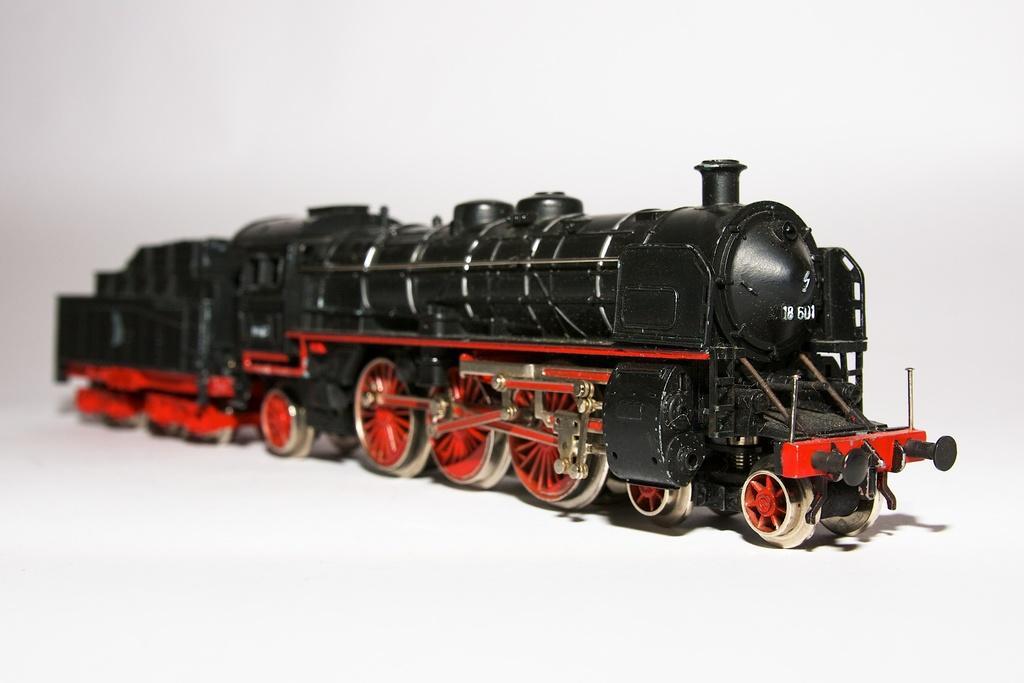Can you describe this image briefly? In the middle of this image, there is a black color toy train having orange color wheels on a surface. And the background is white in color. 